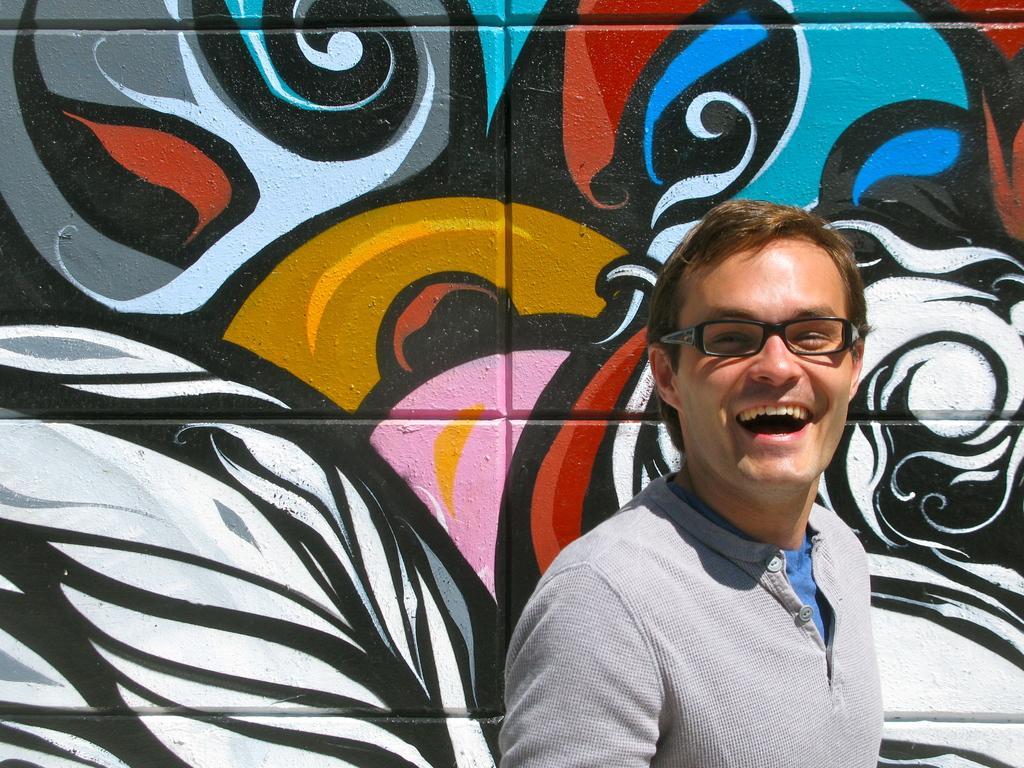Describe this image in one or two sentences. In this image I can see a person and paintings on a wall. This image is taken may be in a day. 